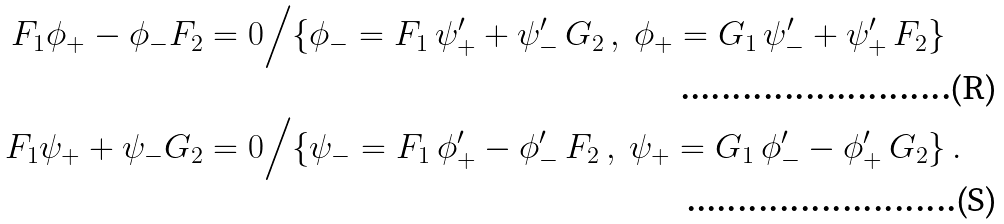<formula> <loc_0><loc_0><loc_500><loc_500>F _ { 1 } \phi _ { + } - \phi _ { - } F _ { 2 } = 0 & \Big / \{ \phi _ { - } = F _ { 1 } \, \psi _ { + } ^ { \prime } + \psi _ { - } ^ { \prime } \, G _ { 2 } \, , \ \phi _ { + } = G _ { 1 } \, \psi _ { - } ^ { \prime } + \psi _ { + } ^ { \prime } \, F _ { 2 } \} \\ F _ { 1 } \psi _ { + } + \psi _ { - } G _ { 2 } = 0 & \Big / \{ \psi _ { - } = F _ { 1 } \, \phi _ { + } ^ { \prime } - \phi _ { - } ^ { \prime } \, F _ { 2 } \, , \ \psi _ { + } = G _ { 1 } \, \phi _ { - } ^ { \prime } - \phi _ { + } ^ { \prime } \, G _ { 2 } \} \, .</formula> 